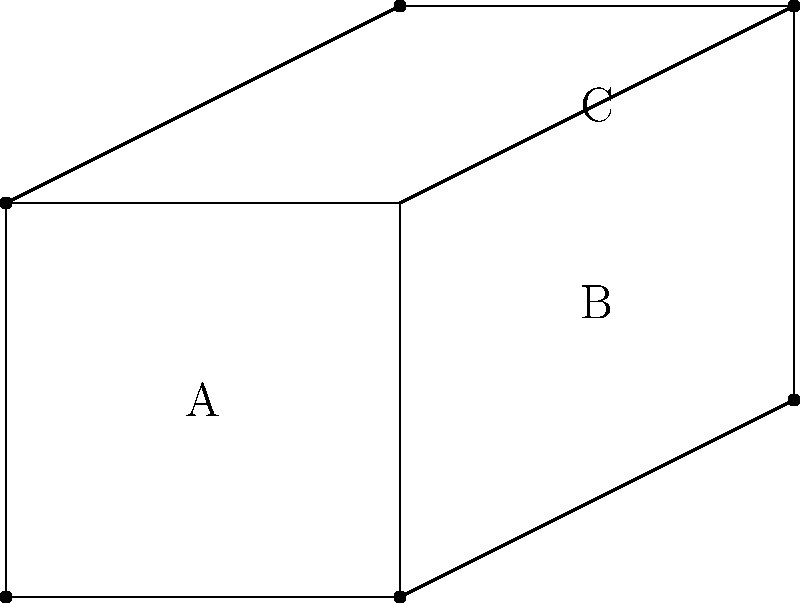Consider the origami-like representation of spacetime curvature shown above. If this structure were to be mentally unfolded and flattened, what would be the angle (in degrees) between the planes containing regions A and C? To solve this problem, let's follow these steps:

1) First, we need to recognize that the diagram represents a 3D structure folded from a 2D plane.

2) Region A is the base plane, while regions B and C are folded upwards.

3) To determine the angle between planes A and C, we need to mentally unfold the structure and observe how plane C relates to plane A.

4) Notice that plane C is connected to plane A through plane B. This means that when unfolded, C will be rotated twice relative to A.

5) The angle between A and B can be calculated by observing the right triangle formed when B is folded up:
   - The base of this triangle is 2 units (the width of A)
   - The height is 1 unit (the vertical rise of B)
   - Using trigonometry: $\tan \theta = \frac{1}{2}$
   - Therefore, $\theta = \arctan(\frac{1}{2}) \approx 26.57°$

6) The angle between B and C is the same as between A and B due to the symmetry of the fold.

7) When unfolded, C will be rotated by this angle twice relative to A.

8) Thus, the total angle between A and C when unfolded is:
   $2 * \arctan(\frac{1}{2}) \approx 53.13°$

9) Rounding to the nearest whole number: 53°
Answer: 53° 